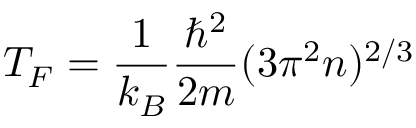<formula> <loc_0><loc_0><loc_500><loc_500>{ T _ { F } = \frac { 1 } { k _ { B } } \frac { \hbar { ^ } { 2 } } { 2 m } ( 3 \pi ^ { 2 } n ) ^ { 2 / 3 } }</formula> 